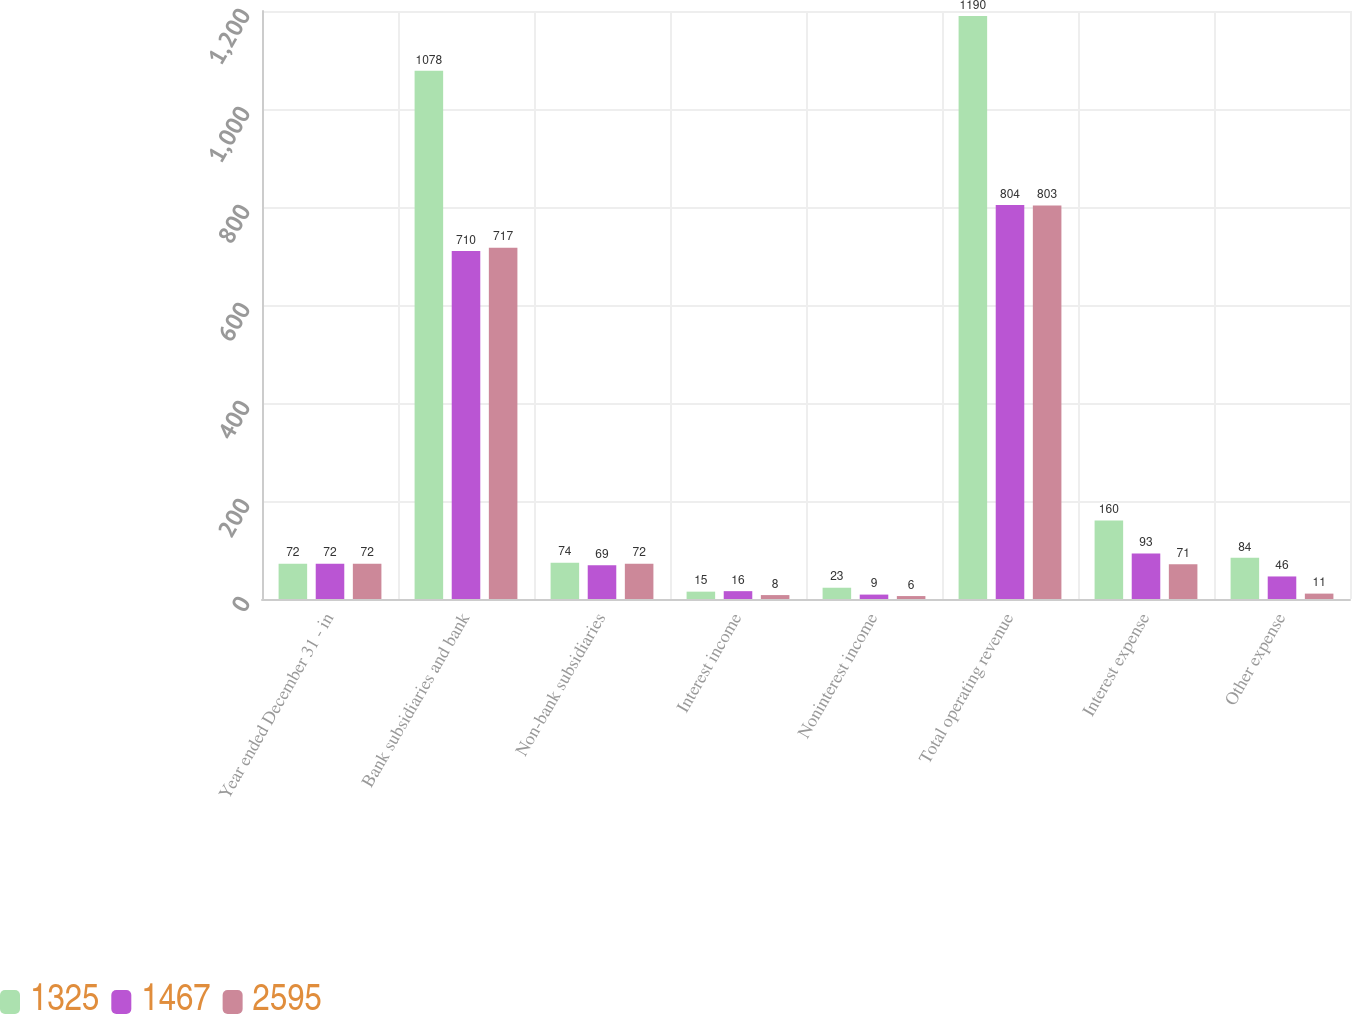Convert chart to OTSL. <chart><loc_0><loc_0><loc_500><loc_500><stacked_bar_chart><ecel><fcel>Year ended December 31 - in<fcel>Bank subsidiaries and bank<fcel>Non-bank subsidiaries<fcel>Interest income<fcel>Noninterest income<fcel>Total operating revenue<fcel>Interest expense<fcel>Other expense<nl><fcel>1325<fcel>72<fcel>1078<fcel>74<fcel>15<fcel>23<fcel>1190<fcel>160<fcel>84<nl><fcel>1467<fcel>72<fcel>710<fcel>69<fcel>16<fcel>9<fcel>804<fcel>93<fcel>46<nl><fcel>2595<fcel>72<fcel>717<fcel>72<fcel>8<fcel>6<fcel>803<fcel>71<fcel>11<nl></chart> 